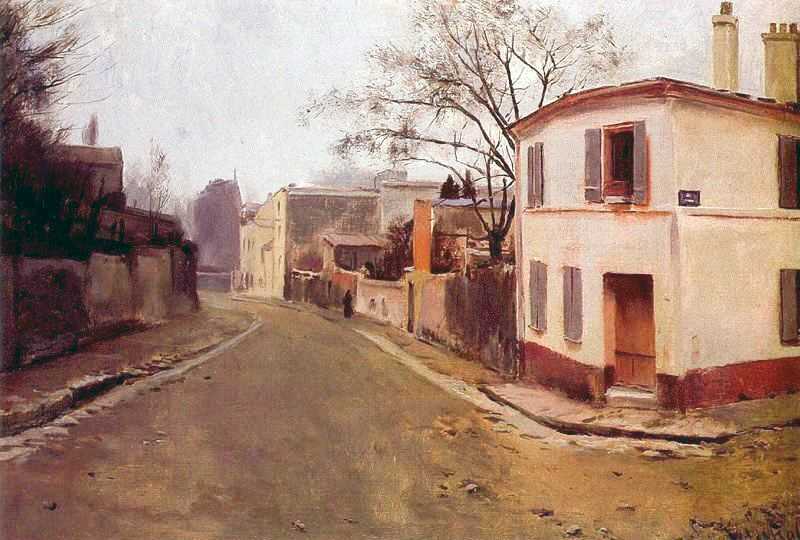If the setting of this painting suddenly turned into a bustling street market, what changes would you imagine? If the setting of this painting suddenly turned into a bustling street market, the tranquil scene would be transformed into a lively panorama filled with activity. Stalls would line the streets, offering various goods such as fresh produce, handcrafted items, and colorful fabrics. The muted tones of the painting would give way to vibrant hues as the market comes alive with bustling vendors and eager shoppers. There would be a cacophony of sounds – the chatter of people haggling, children laughing, and the occasional bark of a street vendor advertising their wares. The scent of freshly baked bread, ripe fruits, and exotic spices would fill the air. While the underlying structure of the street and buildings would remain, the atmosphere would be completely altered, shifting from a sense of serene solitude to one of communal vibrancy and economic activity. 